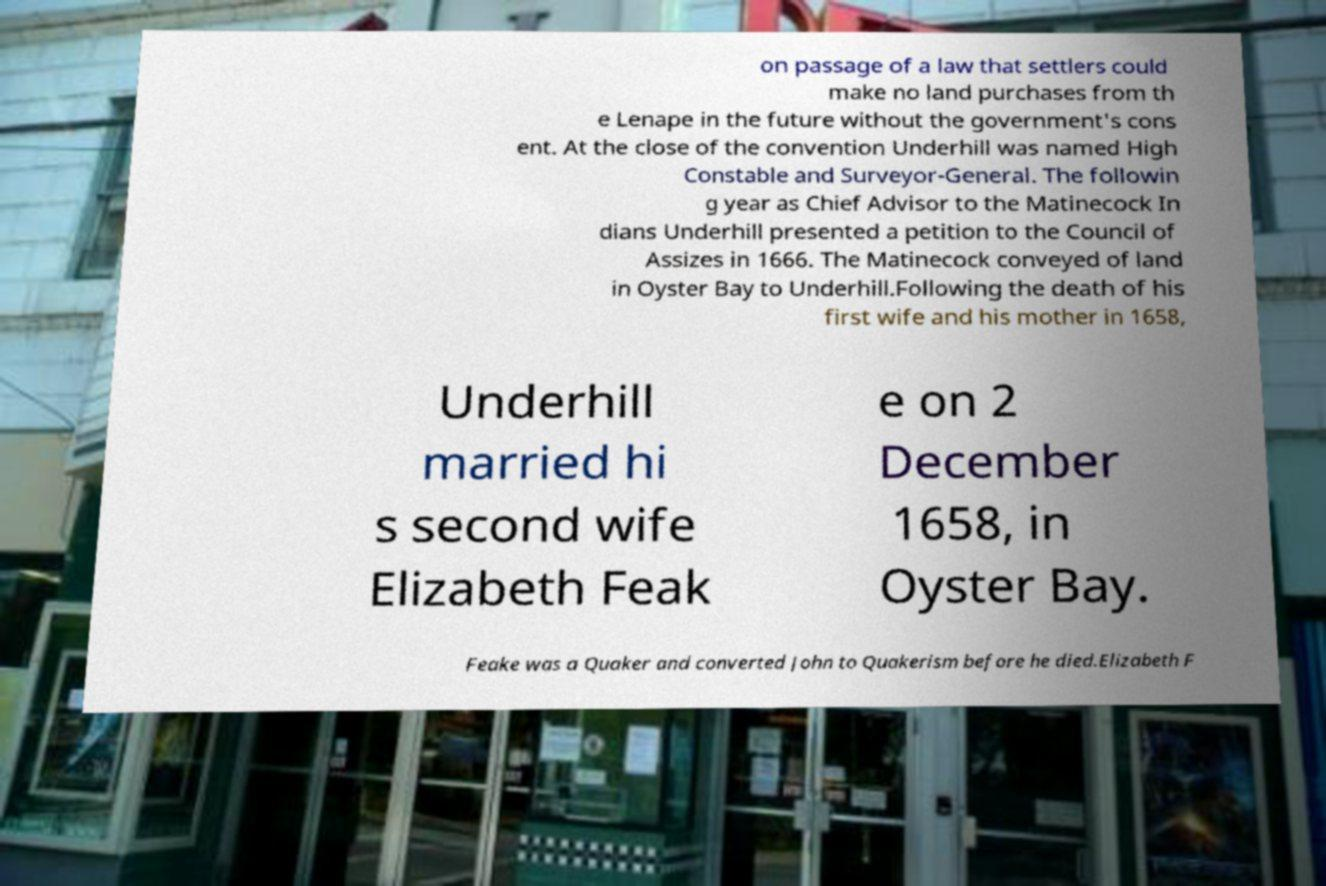There's text embedded in this image that I need extracted. Can you transcribe it verbatim? on passage of a law that settlers could make no land purchases from th e Lenape in the future without the government's cons ent. At the close of the convention Underhill was named High Constable and Surveyor-General. The followin g year as Chief Advisor to the Matinecock In dians Underhill presented a petition to the Council of Assizes in 1666. The Matinecock conveyed of land in Oyster Bay to Underhill.Following the death of his first wife and his mother in 1658, Underhill married hi s second wife Elizabeth Feak e on 2 December 1658, in Oyster Bay. Feake was a Quaker and converted John to Quakerism before he died.Elizabeth F 